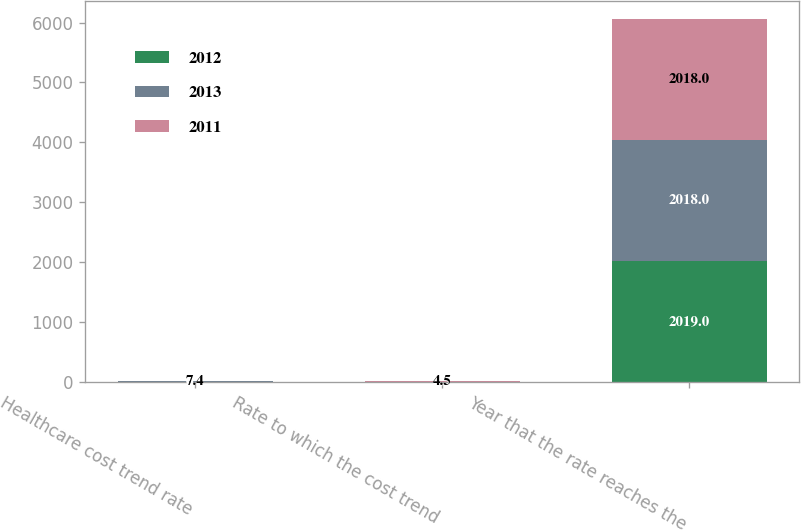<chart> <loc_0><loc_0><loc_500><loc_500><stacked_bar_chart><ecel><fcel>Healthcare cost trend rate<fcel>Rate to which the cost trend<fcel>Year that the rate reaches the<nl><fcel>2012<fcel>6.4<fcel>4.5<fcel>2019<nl><fcel>2013<fcel>6.8<fcel>4.5<fcel>2018<nl><fcel>2011<fcel>7.4<fcel>4.5<fcel>2018<nl></chart> 